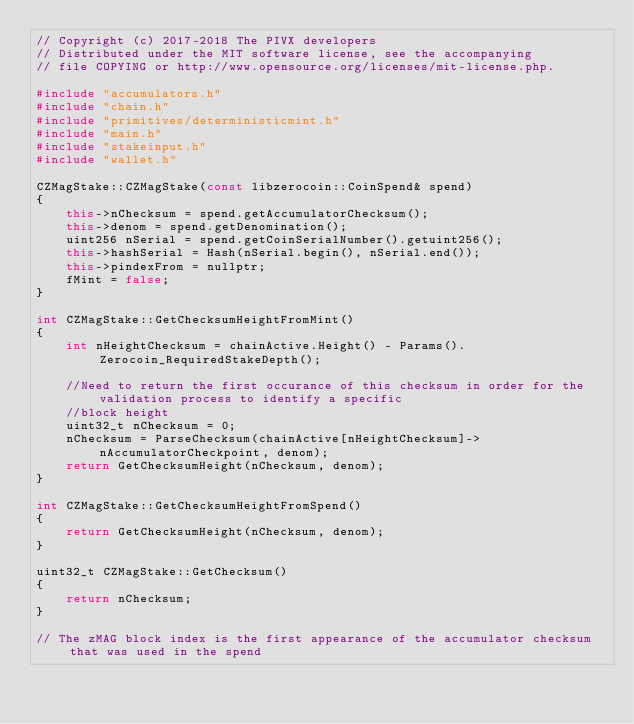Convert code to text. <code><loc_0><loc_0><loc_500><loc_500><_C++_>// Copyright (c) 2017-2018 The PIVX developers
// Distributed under the MIT software license, see the accompanying
// file COPYING or http://www.opensource.org/licenses/mit-license.php.

#include "accumulators.h"
#include "chain.h"
#include "primitives/deterministicmint.h"
#include "main.h"
#include "stakeinput.h"
#include "wallet.h"

CZMagStake::CZMagStake(const libzerocoin::CoinSpend& spend)
{
    this->nChecksum = spend.getAccumulatorChecksum();
    this->denom = spend.getDenomination();
    uint256 nSerial = spend.getCoinSerialNumber().getuint256();
    this->hashSerial = Hash(nSerial.begin(), nSerial.end());
    this->pindexFrom = nullptr;
    fMint = false;
}

int CZMagStake::GetChecksumHeightFromMint()
{
    int nHeightChecksum = chainActive.Height() - Params().Zerocoin_RequiredStakeDepth();

    //Need to return the first occurance of this checksum in order for the validation process to identify a specific
    //block height
    uint32_t nChecksum = 0;
    nChecksum = ParseChecksum(chainActive[nHeightChecksum]->nAccumulatorCheckpoint, denom);
    return GetChecksumHeight(nChecksum, denom);
}

int CZMagStake::GetChecksumHeightFromSpend()
{
    return GetChecksumHeight(nChecksum, denom);
}

uint32_t CZMagStake::GetChecksum()
{
    return nChecksum;
}

// The zMAG block index is the first appearance of the accumulator checksum that was used in the spend</code> 